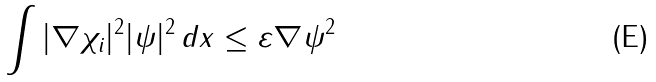Convert formula to latex. <formula><loc_0><loc_0><loc_500><loc_500>\int | \nabla \chi _ { i } | ^ { 2 } | \psi | ^ { 2 } \, d x \leq \varepsilon \| \nabla \psi \| ^ { 2 }</formula> 